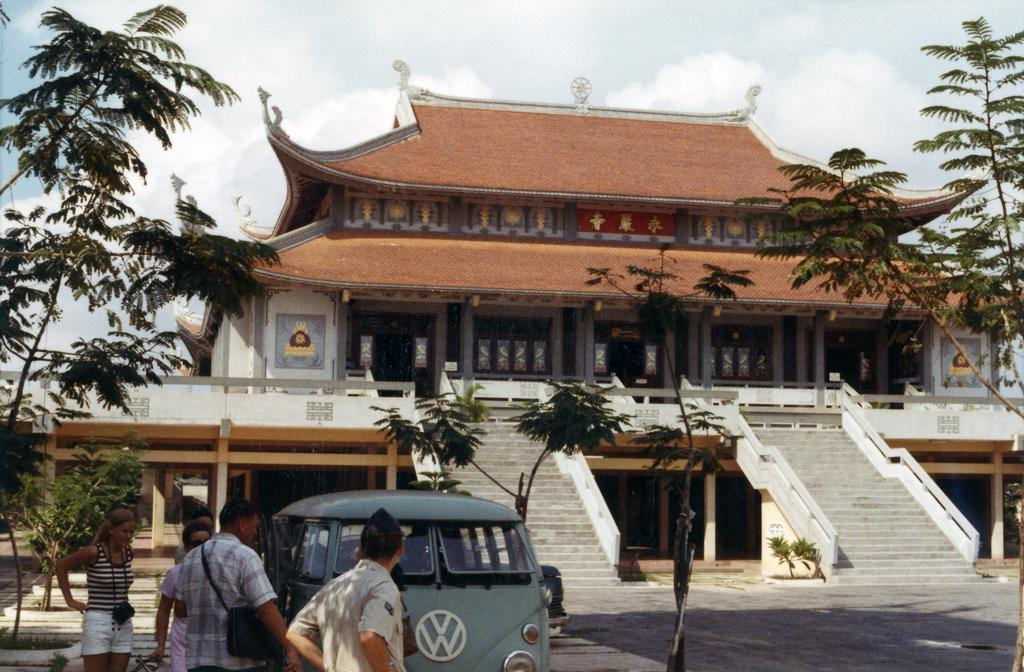What can be seen in the foreground of the picture? There are trees, people, and a van in the foreground of the picture. What is located in the center of the picture? There is a building and a plant in the center of the picture. What is the condition of the sky in the picture? The sky is cloudy in the picture. Where is the pencil located in the picture? There is no pencil present in the image. Can you tell me how many sinks are visible in the picture? There are no sinks visible in the picture. 